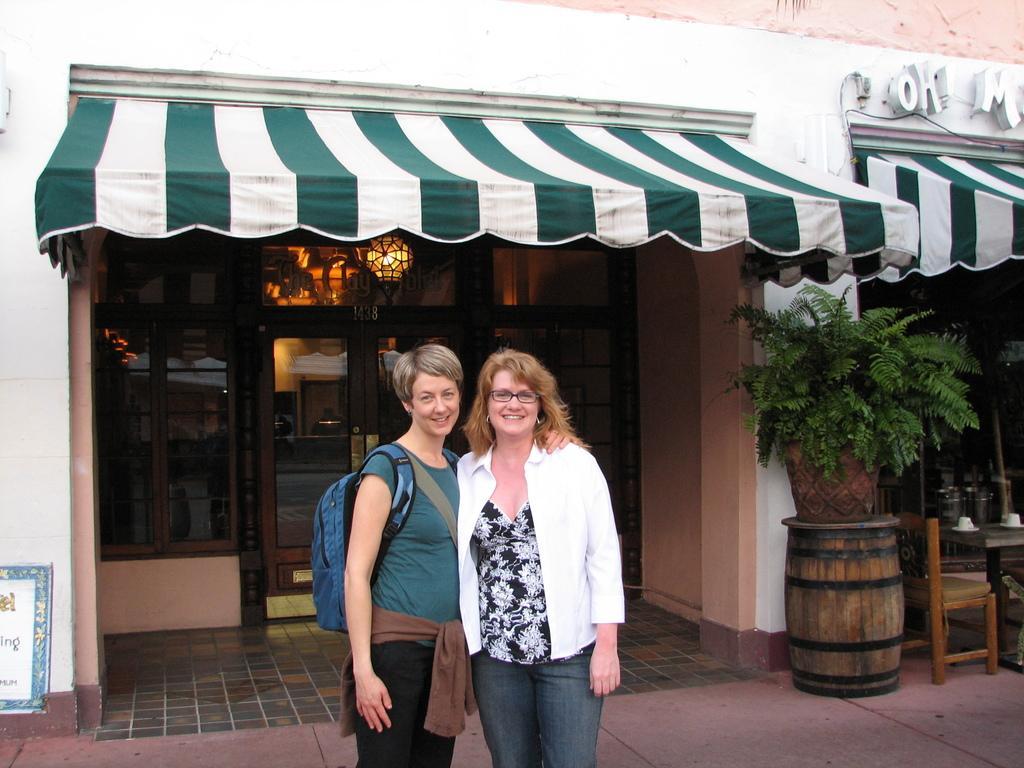How would you summarize this image in a sentence or two? In this image we can see two persons standing and smiling, among them one person is carrying a bag, in the background, we can see a building, there are some windows and doors, in front of the building we can see a houseplant, chair, table and some other objects. 